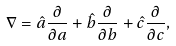Convert formula to latex. <formula><loc_0><loc_0><loc_500><loc_500>\nabla = \hat { a } \frac { \partial } { \partial a } + \hat { b } \frac { \partial } { \partial b } + \hat { c } \frac { \partial } { \partial c } ,</formula> 